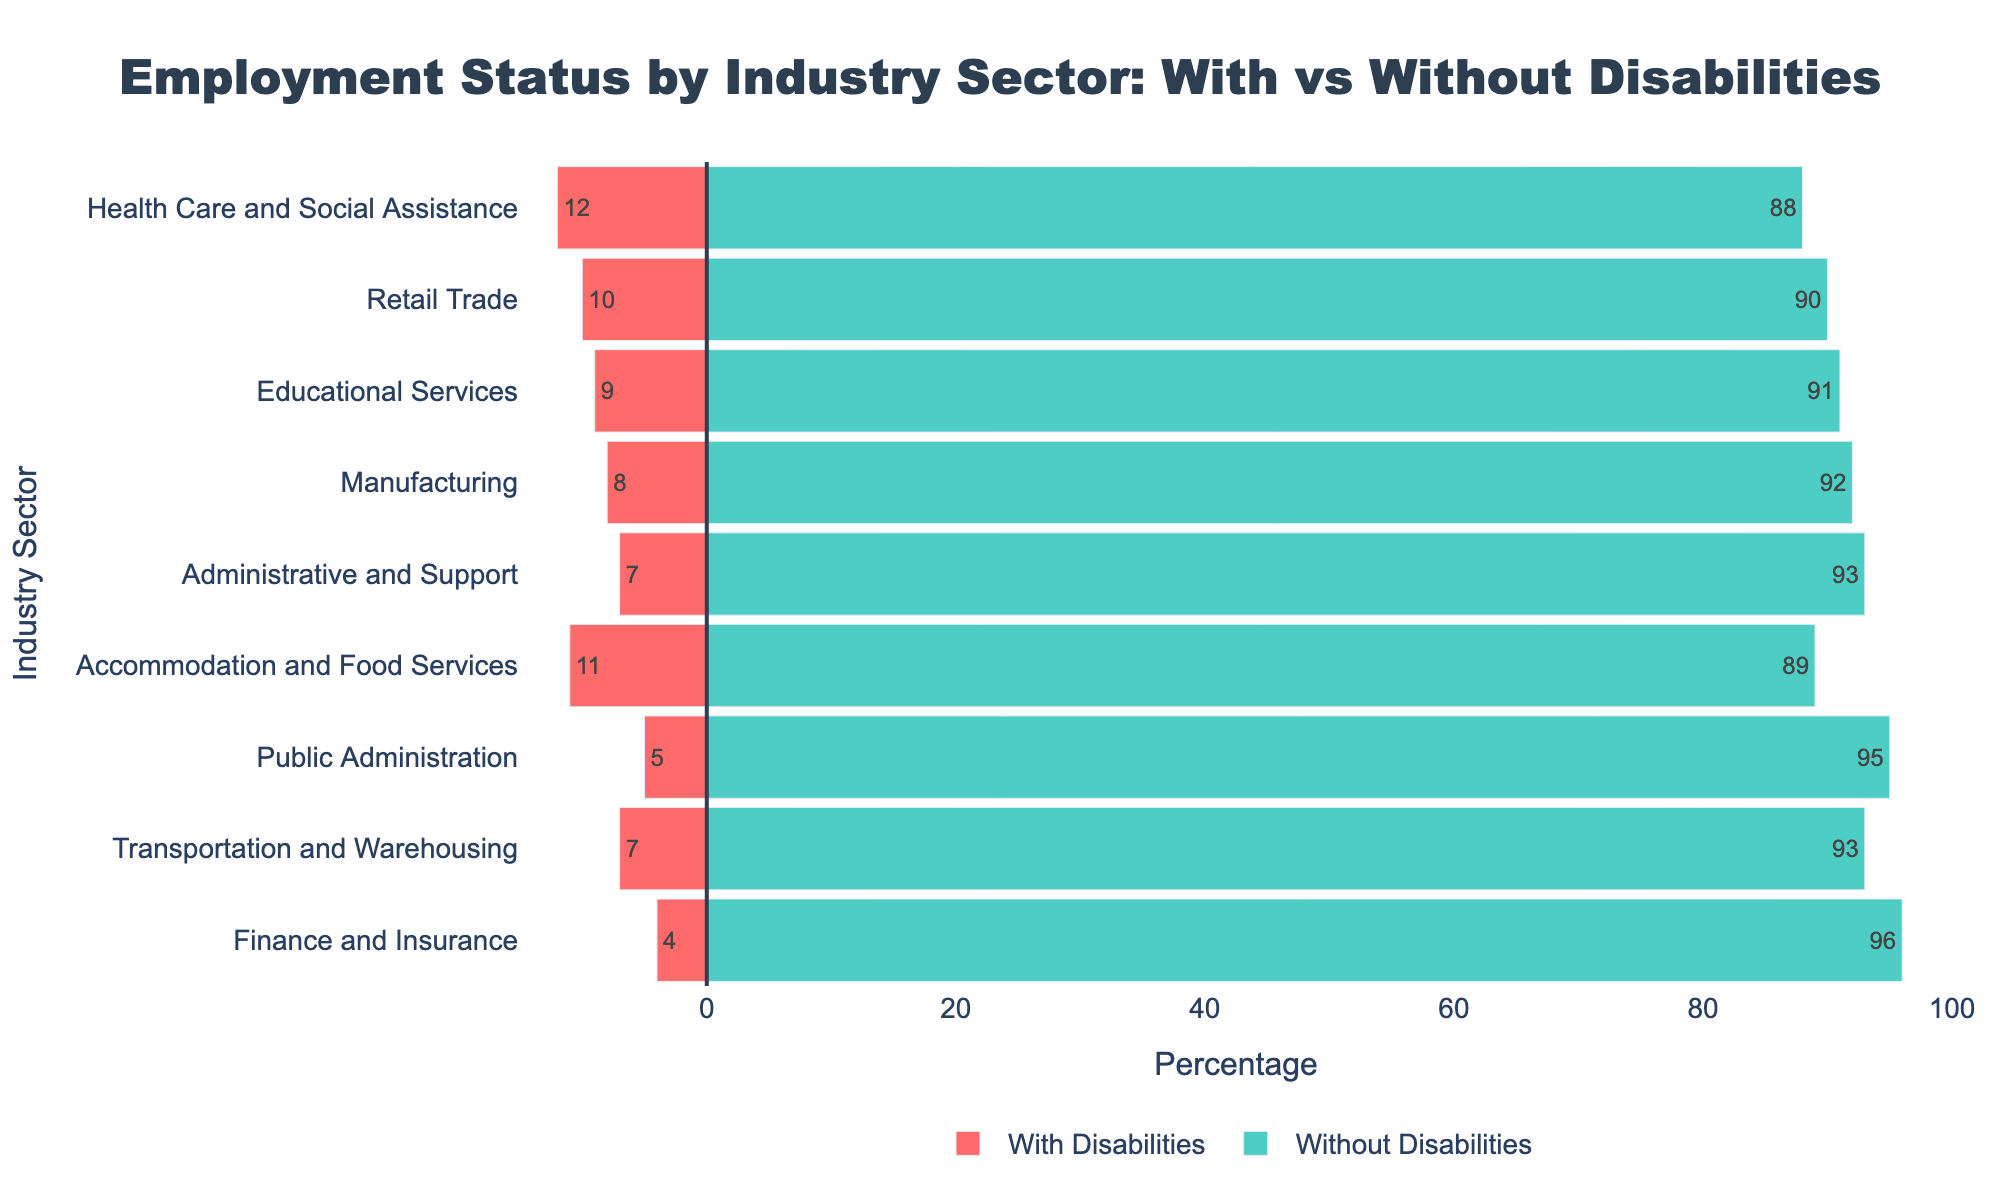What is the industry sector with the highest percentage of individuals with disabilities employed? The tallest red bar represents individuals with disabilities employed, and the highest bar is associated with "Health Care and Social Assistance."
Answer: Health Care and Social Assistance Which industry sector has the lowest percentage of individuals without disabilities employed? The shortest green bar corresponds to individuals without disabilities employed, which is in the "Finance and Insurance" sector.
Answer: Finance and Insurance How does the percentage of individuals with disabilities employed in the Retail Trade sector compare to those in the Accommodation and Food Services sector? In the Retail Trade sector, the percentage is 10%, and in Accommodation and Food Services, it is 11%. Therefore, Accommodation and Food Services has a higher percentage.
Answer: Accommodation and Food Services What is the total percentage of individuals employed (both with and without disabilities) in the Public Administration sector? Sum the absolute values of both percentages in the Public Administration sector: 5% (with disabilities) + 95% (without disabilities) = 100%.
Answer: 100% Which industry sector shows an equal percentage of employment among individuals with and without disabilities? By visual comparison, none of the bars represent equal lengths for individuals with and without disabilities in any sector.
Answer: None What is the difference in employment percentage between individuals with disabilities and without disabilities in the Manufacturing sector? The percentage for individuals with disabilities is 8%, and for those without disabilities, it is 92%. The difference is 92% - 8% = 84%.
Answer: 84% In which industry sector is the disparity between employment percentages (with vs. without disabilities) the greatest? Calculate the disparity for all sectors by subtracting the percentage with disabilities from the percentage without disabilities. The sector with the largest difference is Health Care and Social Assistance (88% - 12% = 76%).
Answer: Health Care and Social Assistance What is the average percentage of individuals with disabilities employed across all industry sectors? Sum the percentages for all sectors and divide by the number of sectors: (12 + 10 + 9 + 8 + 7 + 11 + 5 + 7 + 4)/9 = 8.11%.
Answer: 8.11% How does the percentage of individuals with disabilities employed in Educational Services compare to that in Transportation and Warehousing? In Educational Services, the percentage is 9%, and in Transportation and Warehousing, it is 7%. Educational Services has a higher percentage.
Answer: Educational Services Which two industry sectors have the same percentage of individuals without disabilities employed? By visual inspection, both Administrative and Support, and Transportation and Warehousing sectors have 93% employment without disabilities.
Answer: Administrative and Support, Transportation and Warehousing 